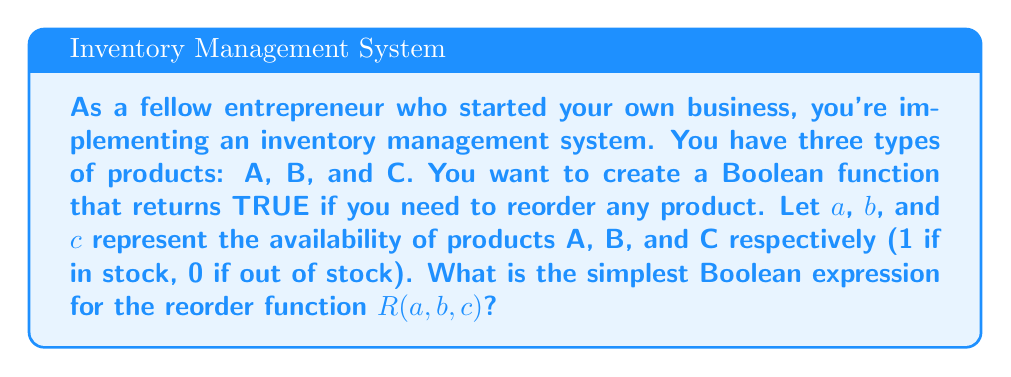What is the answer to this math problem? Let's approach this step-by-step:

1) We need to reorder if any of the products are out of stock. This means we want $R(a,b,c)$ to be TRUE (1) if any of $a$, $b$, or $c$ is 0.

2) We can start by writing the function as:
   $R(a,b,c) = \text{TRUE if } a=0 \text{ OR } b=0 \text{ OR } c=0$

3) In Boolean algebra, this can be written as:
   $R(a,b,c) = \overline{a} + \overline{b} + \overline{c}$

   Where $\overline{x}$ represents the NOT operation, and + represents OR.

4) However, we can simplify this using De Morgan's Law:
   $\overline{a} + \overline{b} + \overline{c} = \overline{abc}$

5) This means that $R(a,b,c)$ will be TRUE (1) if the product $abc$ is FALSE (0).

6) In other words, we only don't need to reorder if all products are in stock (all 1's).

Therefore, the simplest Boolean expression for the reorder function is $R(a,b,c) = \overline{abc}$.
Answer: $R(a,b,c) = \overline{abc}$ 